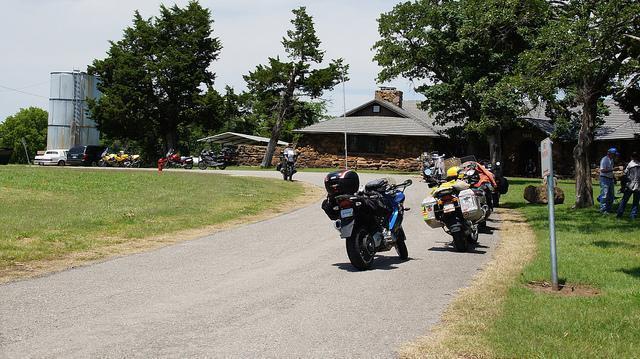How many motorcycles are there?
Give a very brief answer. 2. 